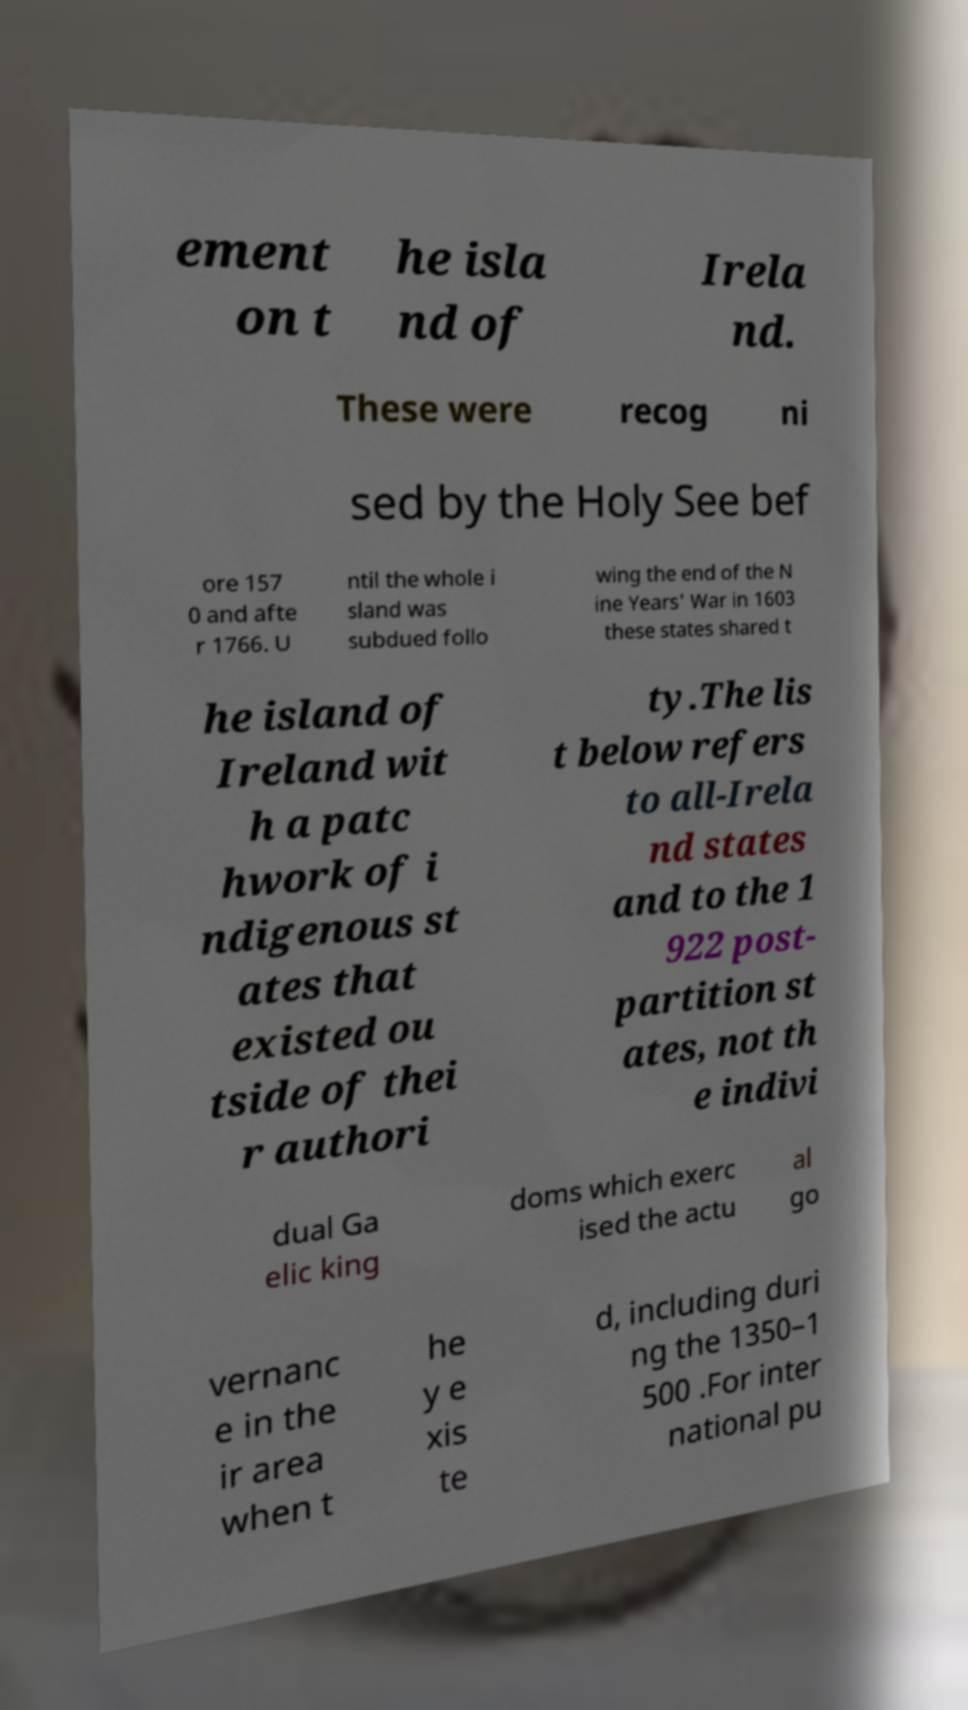What messages or text are displayed in this image? I need them in a readable, typed format. ement on t he isla nd of Irela nd. These were recog ni sed by the Holy See bef ore 157 0 and afte r 1766. U ntil the whole i sland was subdued follo wing the end of the N ine Years' War in 1603 these states shared t he island of Ireland wit h a patc hwork of i ndigenous st ates that existed ou tside of thei r authori ty.The lis t below refers to all-Irela nd states and to the 1 922 post- partition st ates, not th e indivi dual Ga elic king doms which exerc ised the actu al go vernanc e in the ir area when t he y e xis te d, including duri ng the 1350–1 500 .For inter national pu 